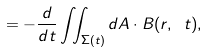Convert formula to latex. <formula><loc_0><loc_0><loc_500><loc_500>= - { \frac { d } { d t } } \iint _ { \Sigma ( t ) } d { A } \cdot B ( r , \ t ) ,</formula> 